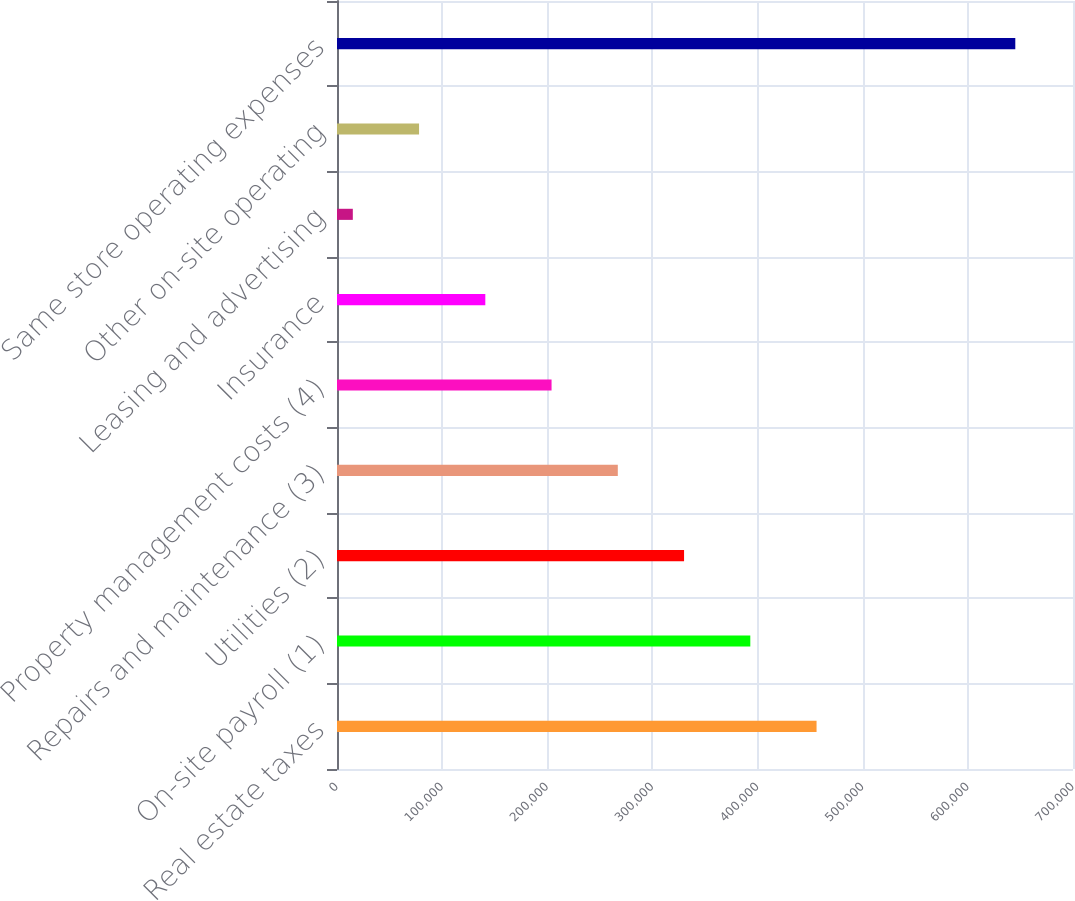Convert chart. <chart><loc_0><loc_0><loc_500><loc_500><bar_chart><fcel>Real estate taxes<fcel>On-site payroll (1)<fcel>Utilities (2)<fcel>Repairs and maintenance (3)<fcel>Property management costs (4)<fcel>Insurance<fcel>Leasing and advertising<fcel>Other on-site operating<fcel>Same store operating expenses<nl><fcel>456099<fcel>393091<fcel>330083<fcel>267075<fcel>204067<fcel>141059<fcel>15043<fcel>78051<fcel>645123<nl></chart> 